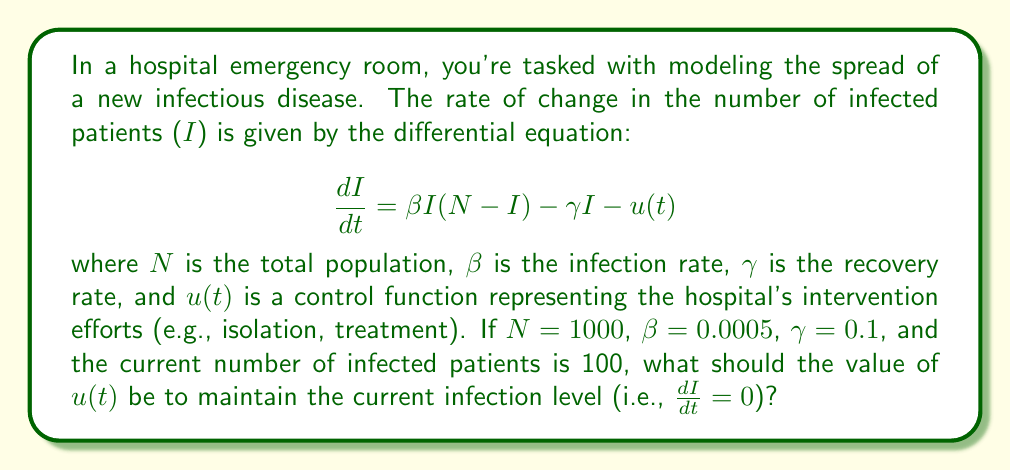Give your solution to this math problem. Let's approach this step-by-step:

1) We're given the differential equation:
   $$\frac{dI}{dt} = \beta I(N-I) - \gamma I - u(t)$$

2) We want to find $u(t)$ when $\frac{dI}{dt} = 0$ (to maintain the current infection level). So, we set the equation to zero:
   $$0 = \beta I(N-I) - \gamma I - u(t)$$

3) We're given the following values:
   $N = 1000$
   $\beta = 0.0005$
   $\gamma = 0.1$
   $I = 100$ (current number of infected patients)

4) Let's substitute these values into our equation:
   $$0 = 0.0005 \cdot 100(1000-100) - 0.1 \cdot 100 - u(t)$$

5) Simplify:
   $$0 = 0.0005 \cdot 100 \cdot 900 - 10 - u(t)$$
   $$0 = 45 - 10 - u(t)$$
   $$0 = 35 - u(t)$$

6) Solve for $u(t)$:
   $$u(t) = 35$$

This means that to maintain the current infection level of 100 patients, the hospital's intervention efforts (represented by $u(t)$) should be equivalent to removing 35 patients from the infected population per unit time.
Answer: $u(t) = 35$ 